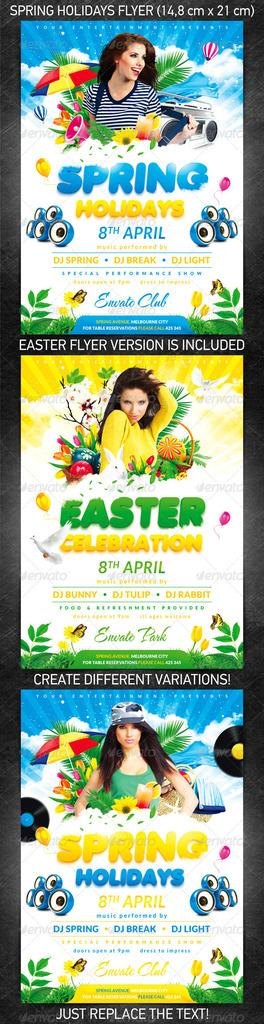<image>
Offer a succinct explanation of the picture presented. A flyer shows different covers for Spring Holidays April show. 